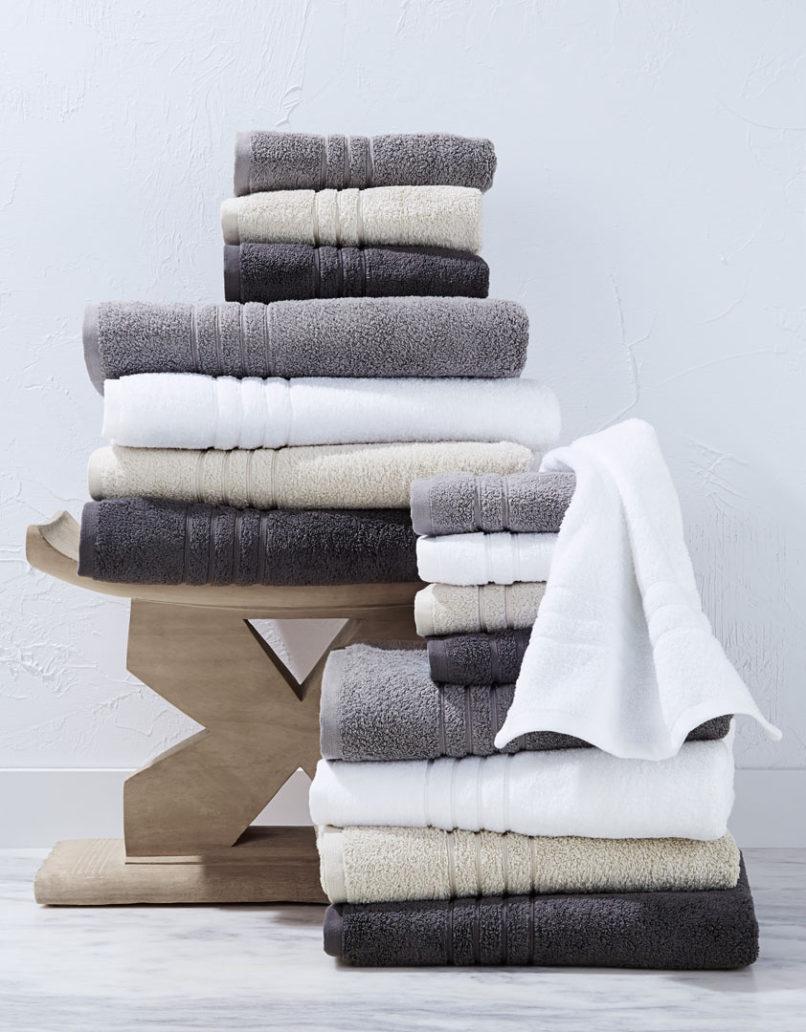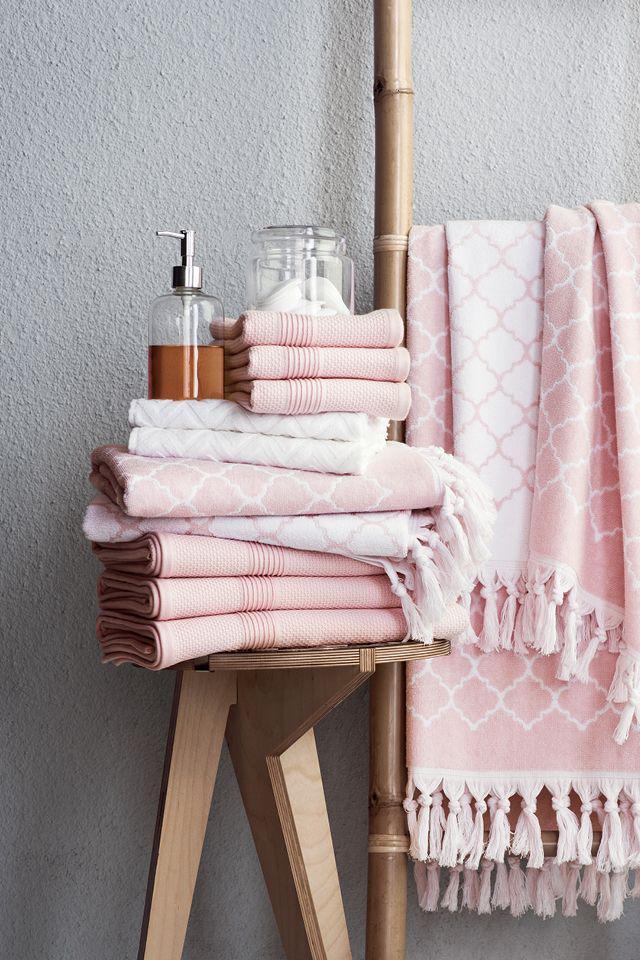The first image is the image on the left, the second image is the image on the right. Considering the images on both sides, is "A toilet is visible in the right image." valid? Answer yes or no. No. The first image is the image on the left, the second image is the image on the right. Considering the images on both sides, is "There are objects sitting on bath towels." valid? Answer yes or no. Yes. 